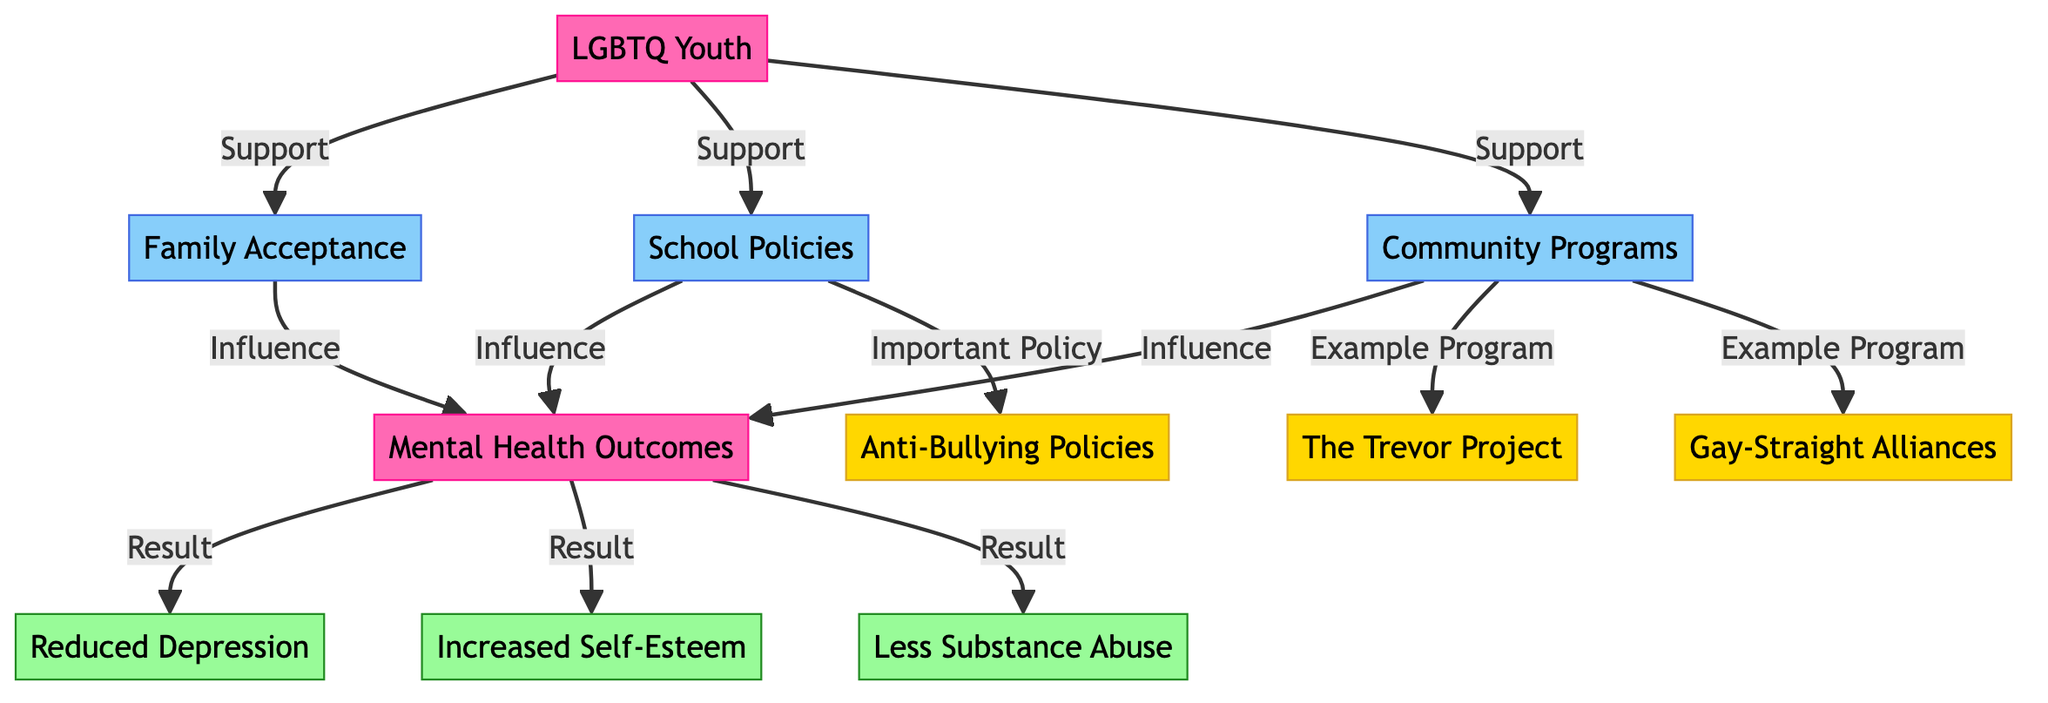What are the three main support systems available for LGBTQ youth? The diagram clearly shows three main support systems connected to LGBTQ youth: Family Acceptance, School Policies, and Community Programs. Each support system is represented as a separate node, which visually signifies its importance.
Answer: Family Acceptance, School Policies, Community Programs How many mental health outcomes are listed? The outcome nodes outlined in the diagram indicate three specific mental health outcomes associated with the support systems: Reduced Depression, Increased Self-Esteem, and Less Substance Abuse. Counting these nodes gives the total.
Answer: 3 What is the influence of Family Acceptance on mental health outcomes? In the diagram, there is a direct connection showing that Family Acceptance influences Mental Health Outcomes. The arrows connecting Family Acceptance to Mental Health Outcomes symbolize this influence.
Answer: Influence Which program is an example of a community program? Among the nodes connected to Community Programs, The Trevor Project and Gay-Straight Alliances are specifically listed as examples. Checking these connections confirms the link.
Answer: The Trevor Project, Gay-Straight Alliances Which type of policy is emphasized in the diagram? The diagram features a node labeled Anti-Bullying Policies which is connected to School Policies. This signifies that Anti-Bullying Policies are recognized as important within the context of school support.
Answer: Important Policy How do the support systems affect the mental health outcomes? The diagram demonstrates that there are arrows from Family Acceptance, School Policies, and Community Programs leading to Mental Health Outcomes, indicating that each support system has a positive influence or effect on the mental health outcomes listed. This connection summarizes the reasoning that support may improve youth mental health.
Answer: Influence What are the three mental health outcomes depicted? The outcomes are visually represented in the diagram and include Reduced Depression, Increased Self-Esteem, and Less Substance Abuse, which are displayed in their respective outcome nodes for clarity.
Answer: Reduced Depression, Increased Self-Esteem, Less Substance Abuse Which node represents LGBTQ Youth in the diagram? The main node labeled LGBTQ Youth is clearly defined at the starting point of the diagram's flow. This distinct labeling indicates its foundational role in the entire support system structure.
Answer: LGBTQ Youth What does the arrow from Community Programs to Mental Health Outcomes indicate? The arrow demonstrates that Community Programs have a direct influence on Mental Health Outcomes, representing that increased support from community programs is linked to improvements in mental health for LGBTQ youth.
Answer: Influence 